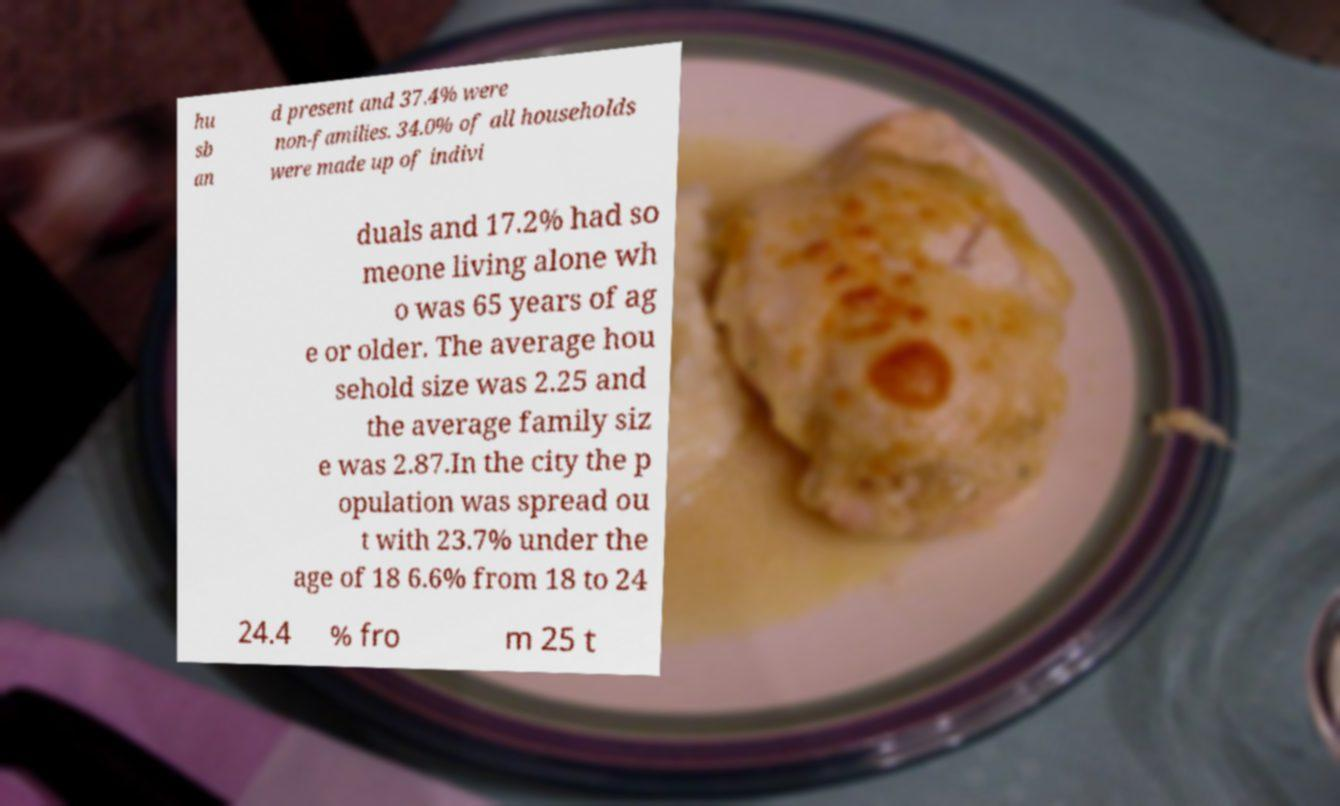Could you extract and type out the text from this image? hu sb an d present and 37.4% were non-families. 34.0% of all households were made up of indivi duals and 17.2% had so meone living alone wh o was 65 years of ag e or older. The average hou sehold size was 2.25 and the average family siz e was 2.87.In the city the p opulation was spread ou t with 23.7% under the age of 18 6.6% from 18 to 24 24.4 % fro m 25 t 